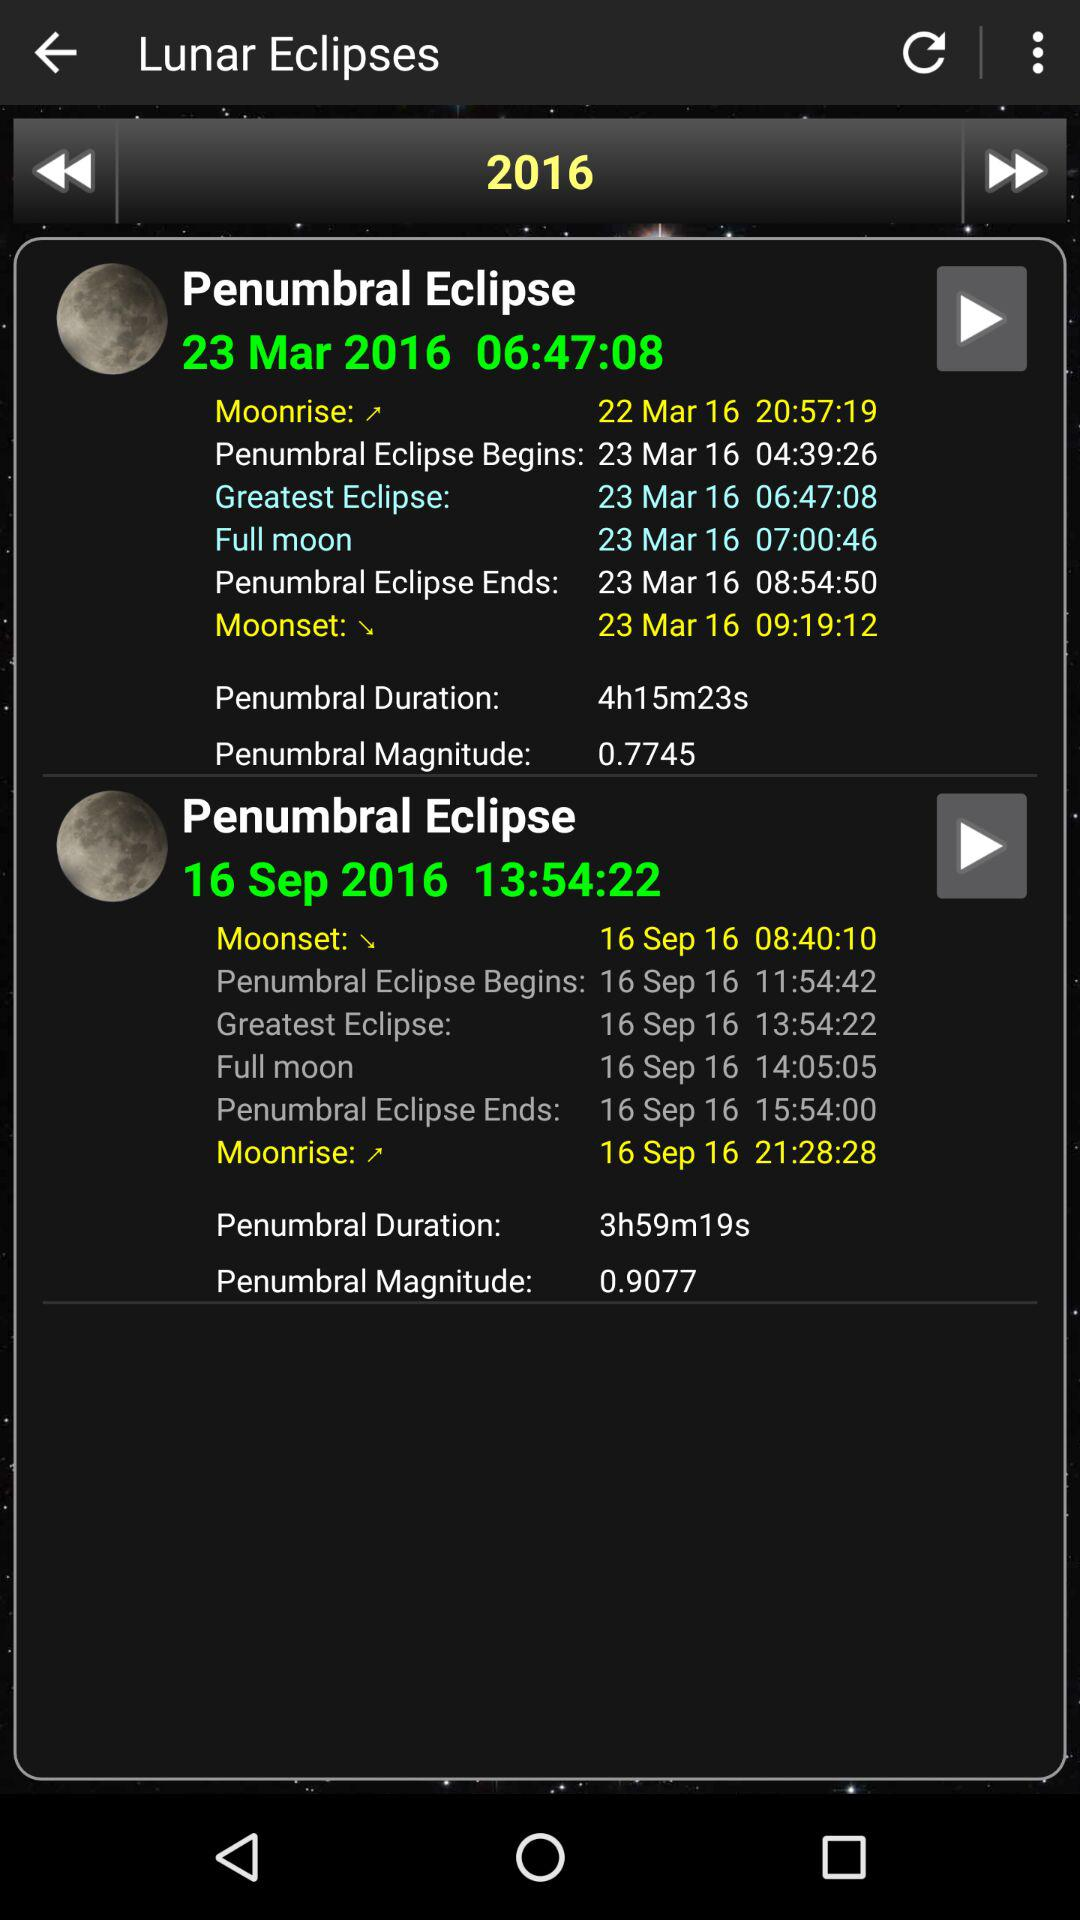How much penumbral magnitude is mentioned? The magnitude is 0.9077. 